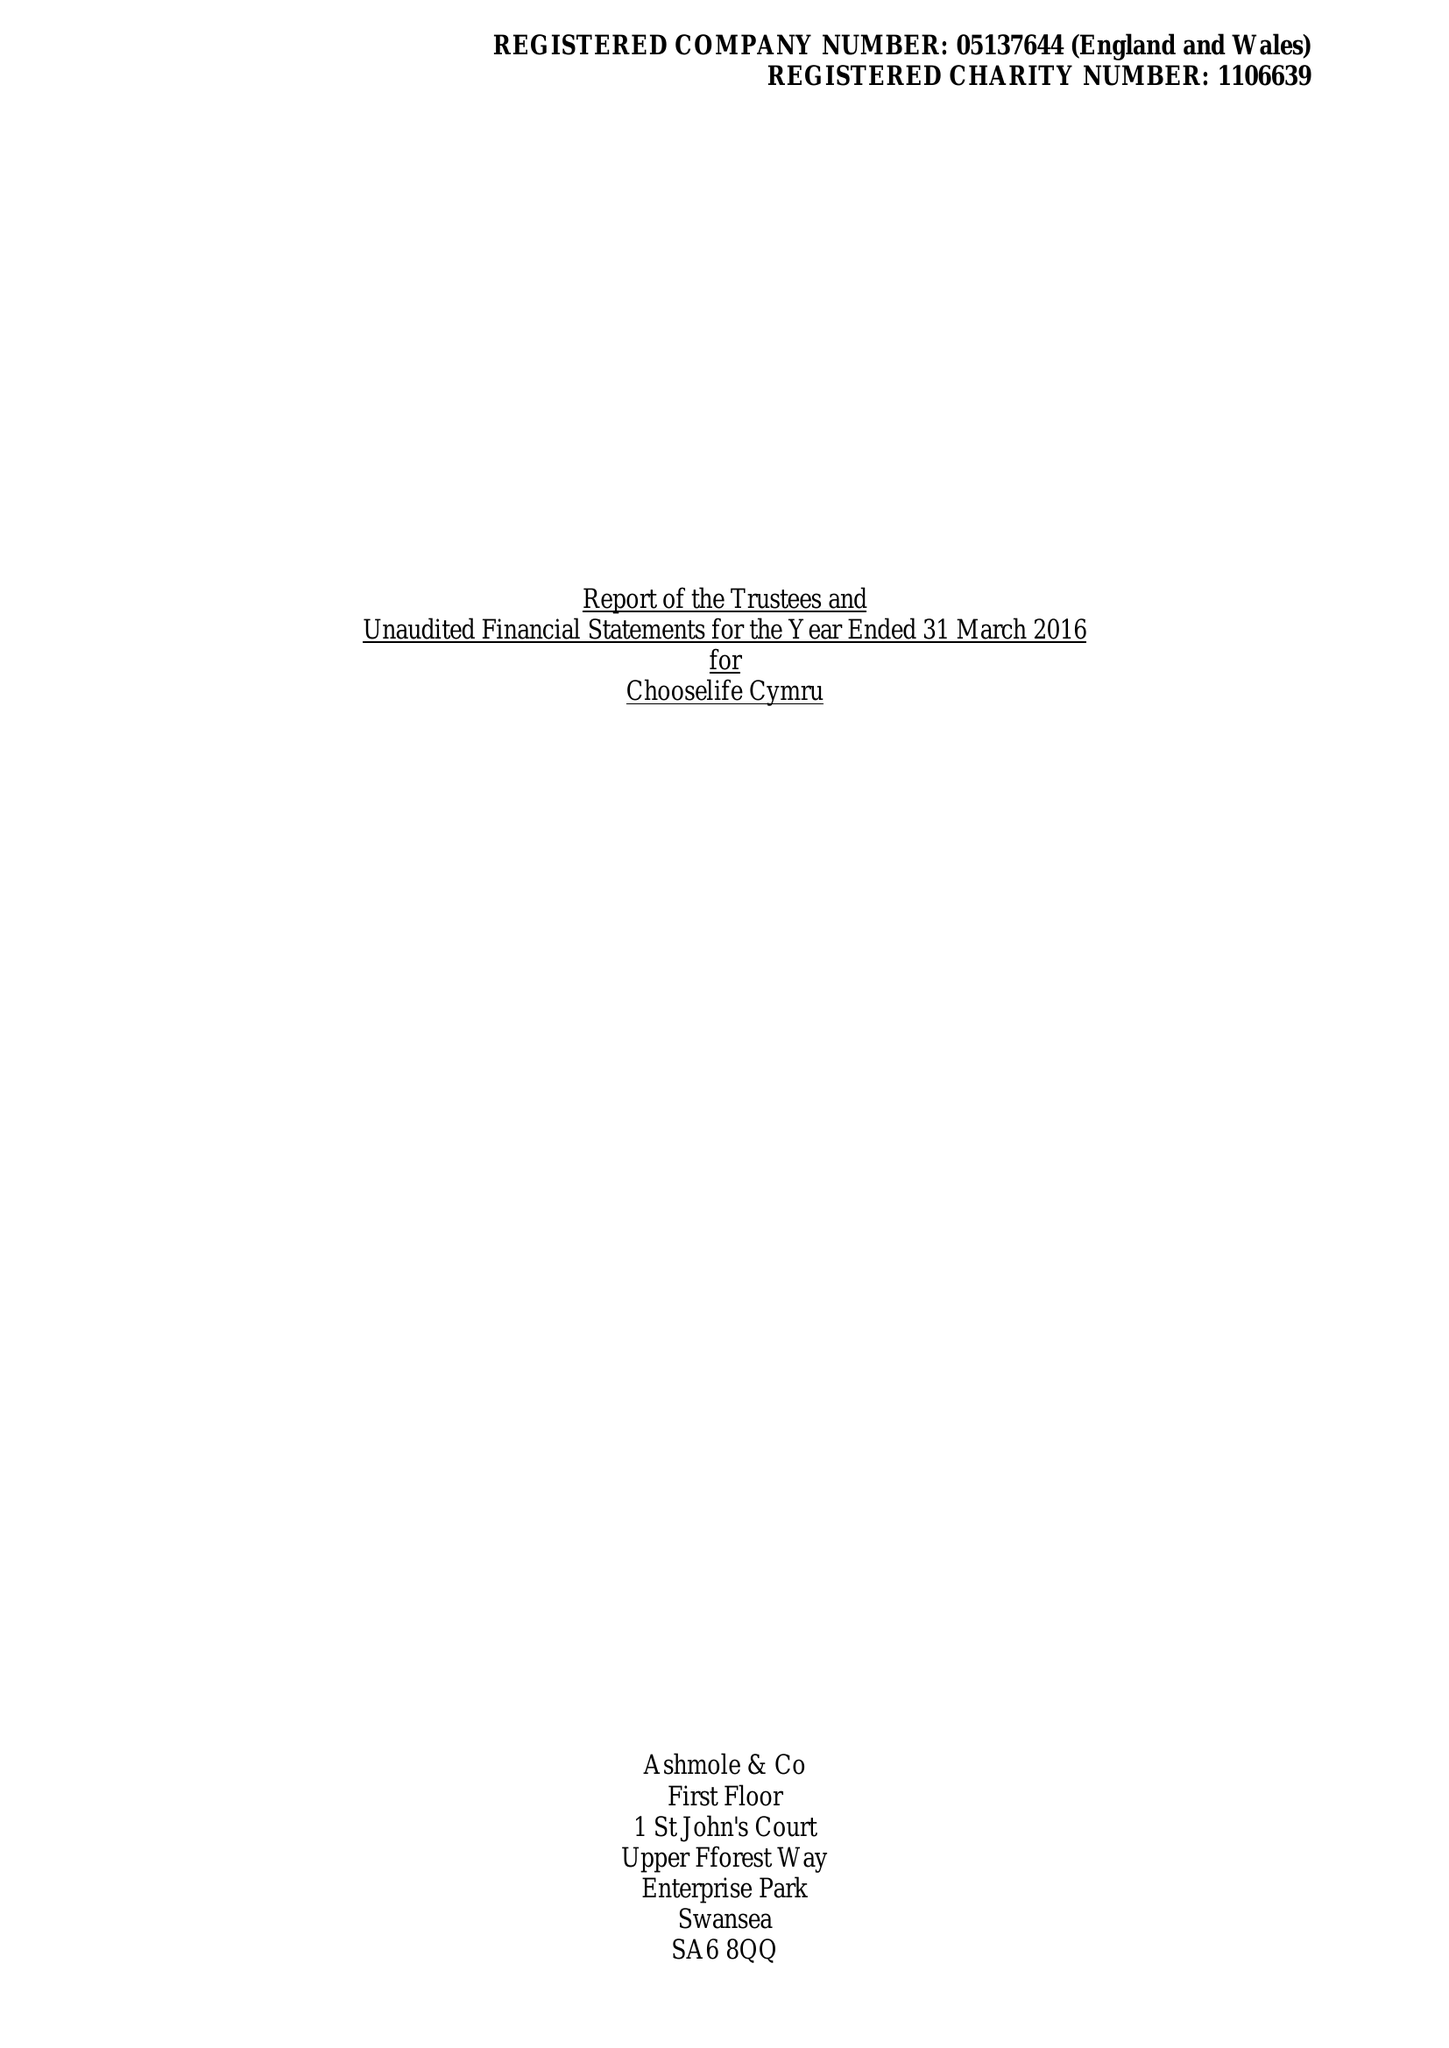What is the value for the income_annually_in_british_pounds?
Answer the question using a single word or phrase. 400137.00 